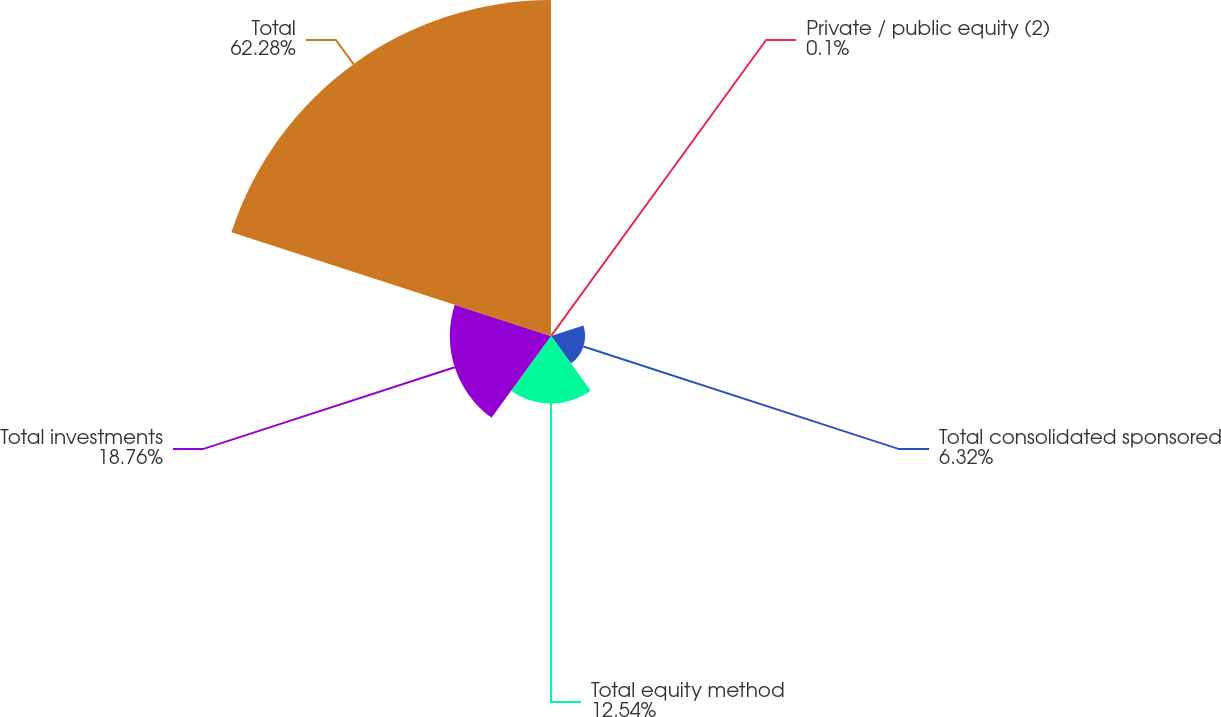Convert chart to OTSL. <chart><loc_0><loc_0><loc_500><loc_500><pie_chart><fcel>Private / public equity (2)<fcel>Total consolidated sponsored<fcel>Total equity method<fcel>Total investments<fcel>Total<nl><fcel>0.1%<fcel>6.32%<fcel>12.54%<fcel>18.76%<fcel>62.29%<nl></chart> 